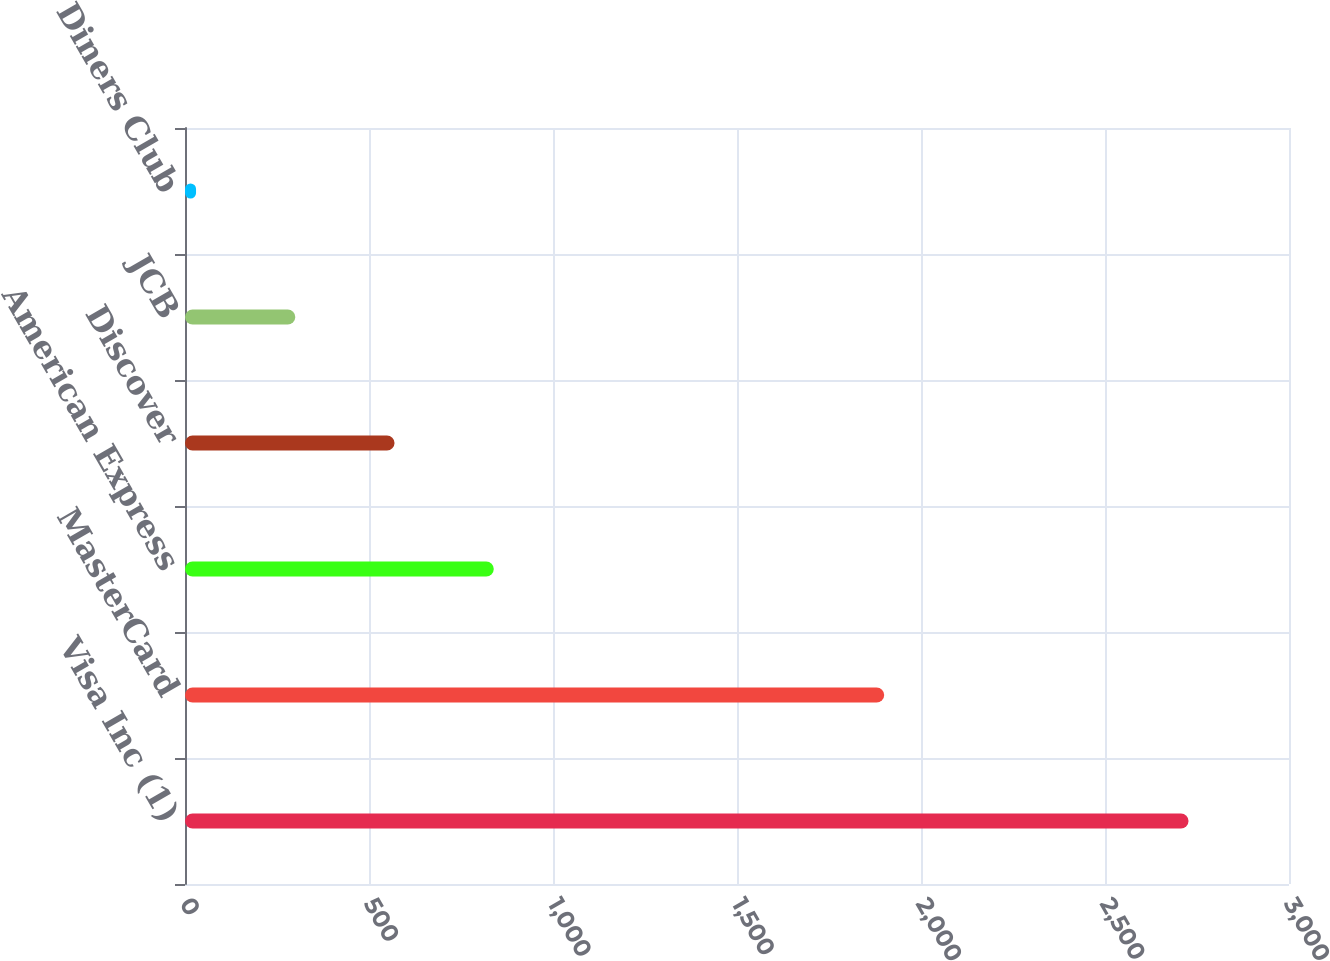Convert chart to OTSL. <chart><loc_0><loc_0><loc_500><loc_500><bar_chart><fcel>Visa Inc (1)<fcel>MasterCard<fcel>American Express<fcel>Discover<fcel>JCB<fcel>Diners Club<nl><fcel>2727<fcel>1900<fcel>839.1<fcel>569.4<fcel>299.7<fcel>30<nl></chart> 